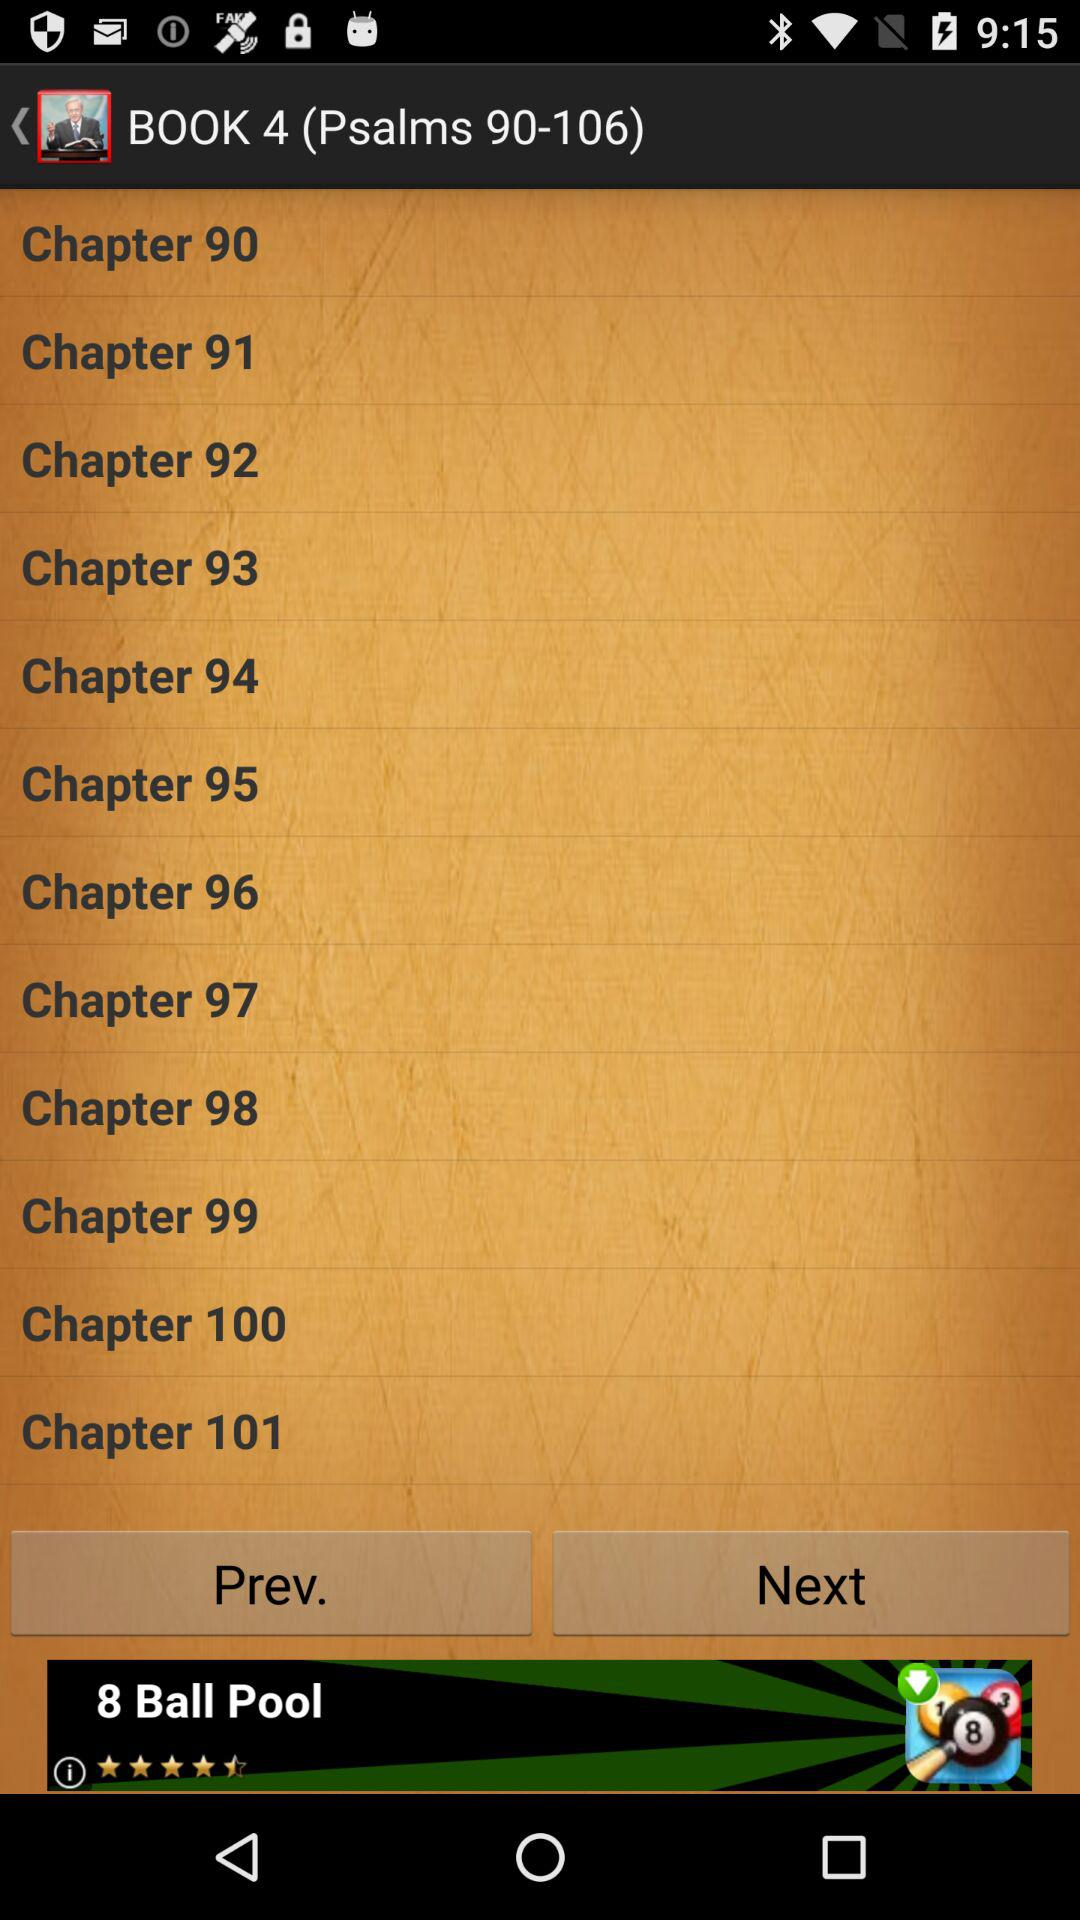Which book contains Psalms 107–150? The book that contains Psalm 107–150 is "BOOK 5". 